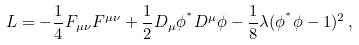<formula> <loc_0><loc_0><loc_500><loc_500>L = - \frac { 1 } { 4 } F _ { \mu \nu } F ^ { \mu \nu } + \frac { 1 } { 2 } D _ { \mu } \phi ^ { ^ { * } } D ^ { \mu } \phi - \frac { 1 } { 8 } \lambda ( \phi ^ { ^ { * } } \phi - 1 ) ^ { 2 } \, ,</formula> 